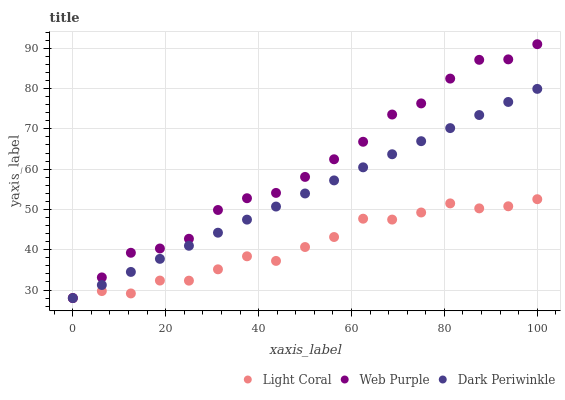Does Light Coral have the minimum area under the curve?
Answer yes or no. Yes. Does Web Purple have the maximum area under the curve?
Answer yes or no. Yes. Does Dark Periwinkle have the minimum area under the curve?
Answer yes or no. No. Does Dark Periwinkle have the maximum area under the curve?
Answer yes or no. No. Is Dark Periwinkle the smoothest?
Answer yes or no. Yes. Is Web Purple the roughest?
Answer yes or no. Yes. Is Web Purple the smoothest?
Answer yes or no. No. Is Dark Periwinkle the roughest?
Answer yes or no. No. Does Light Coral have the lowest value?
Answer yes or no. Yes. Does Web Purple have the highest value?
Answer yes or no. Yes. Does Dark Periwinkle have the highest value?
Answer yes or no. No. Does Dark Periwinkle intersect Light Coral?
Answer yes or no. Yes. Is Dark Periwinkle less than Light Coral?
Answer yes or no. No. Is Dark Periwinkle greater than Light Coral?
Answer yes or no. No. 